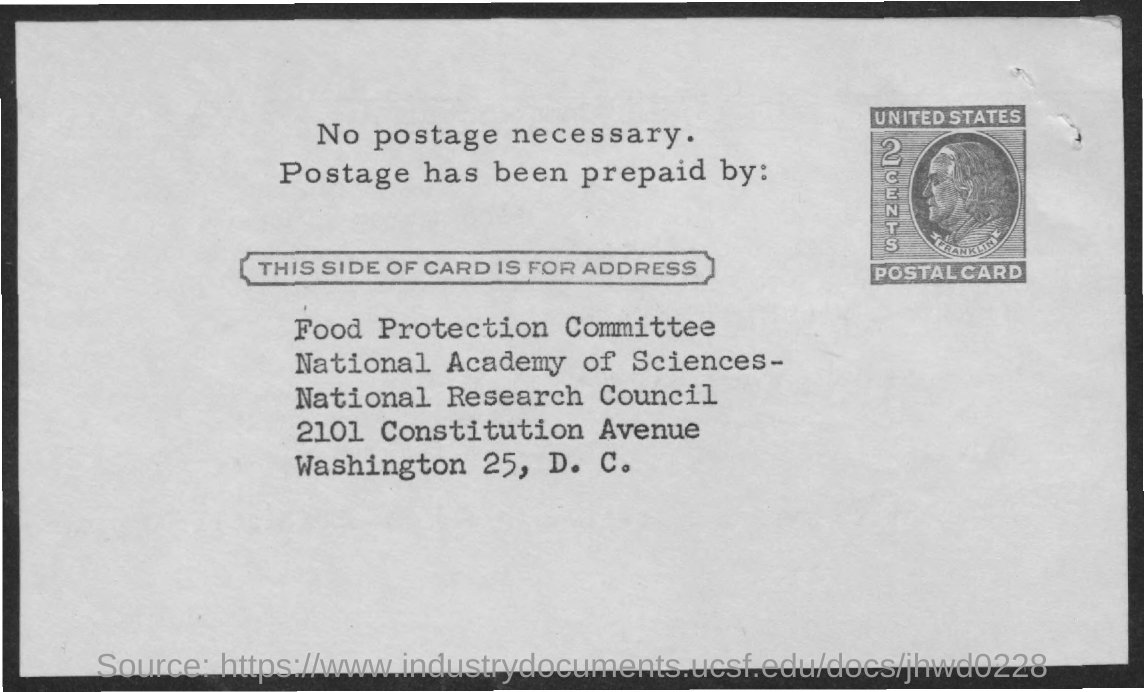Indicate a few pertinent items in this graphic. The cost of postage is two cents. The Food Protection Committee is the name of the committee mentioned in the address. 